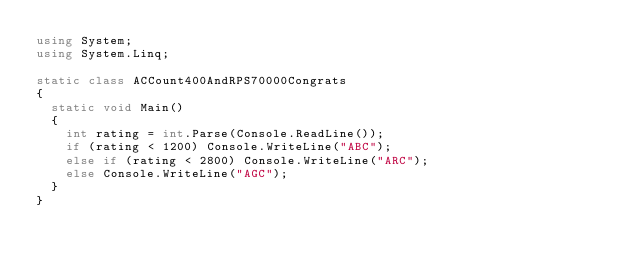<code> <loc_0><loc_0><loc_500><loc_500><_C#_>using System;
using System.Linq;

static class ACCount400AndRPS70000Congrats
{
  static void Main()
  {
    int rating = int.Parse(Console.ReadLine());
    if (rating < 1200) Console.WriteLine("ABC");
    else if (rating < 2800) Console.WriteLine("ARC");
    else Console.WriteLine("AGC");
  }
}</code> 